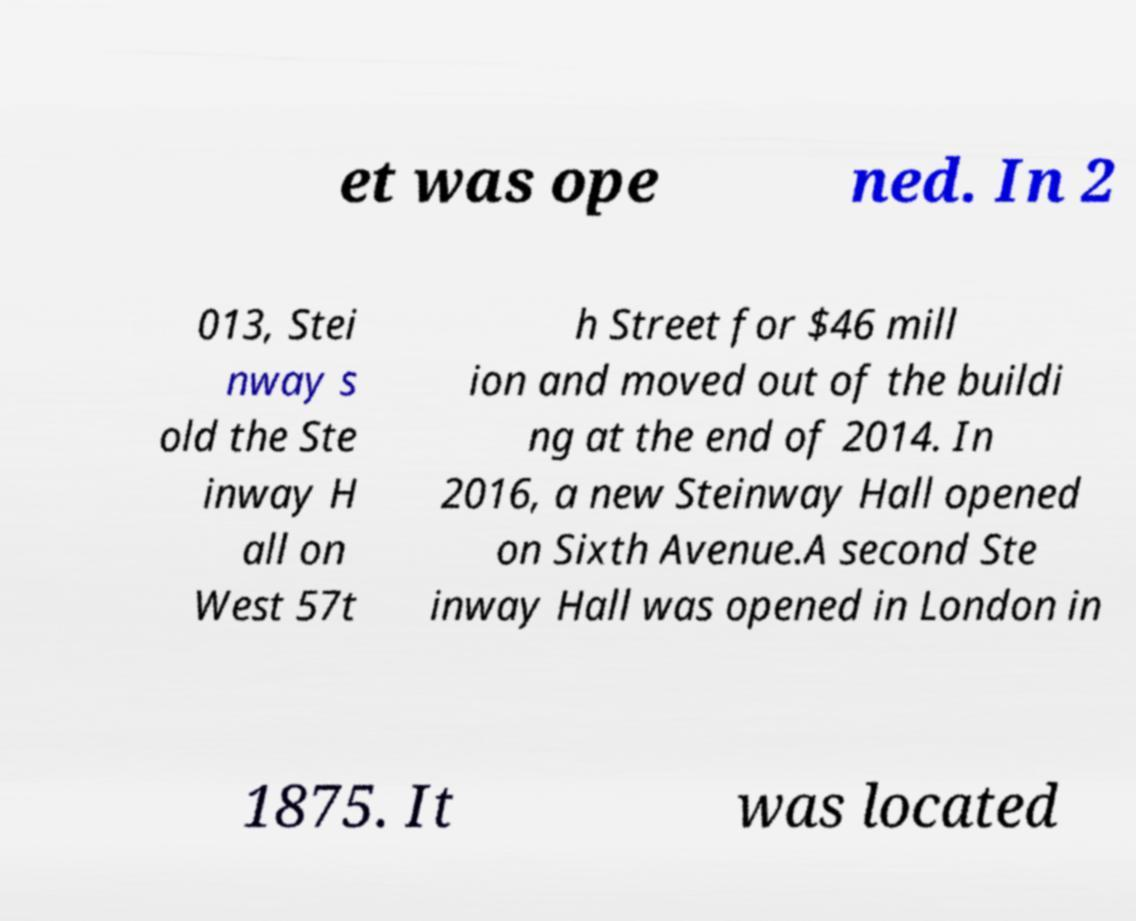For documentation purposes, I need the text within this image transcribed. Could you provide that? et was ope ned. In 2 013, Stei nway s old the Ste inway H all on West 57t h Street for $46 mill ion and moved out of the buildi ng at the end of 2014. In 2016, a new Steinway Hall opened on Sixth Avenue.A second Ste inway Hall was opened in London in 1875. It was located 